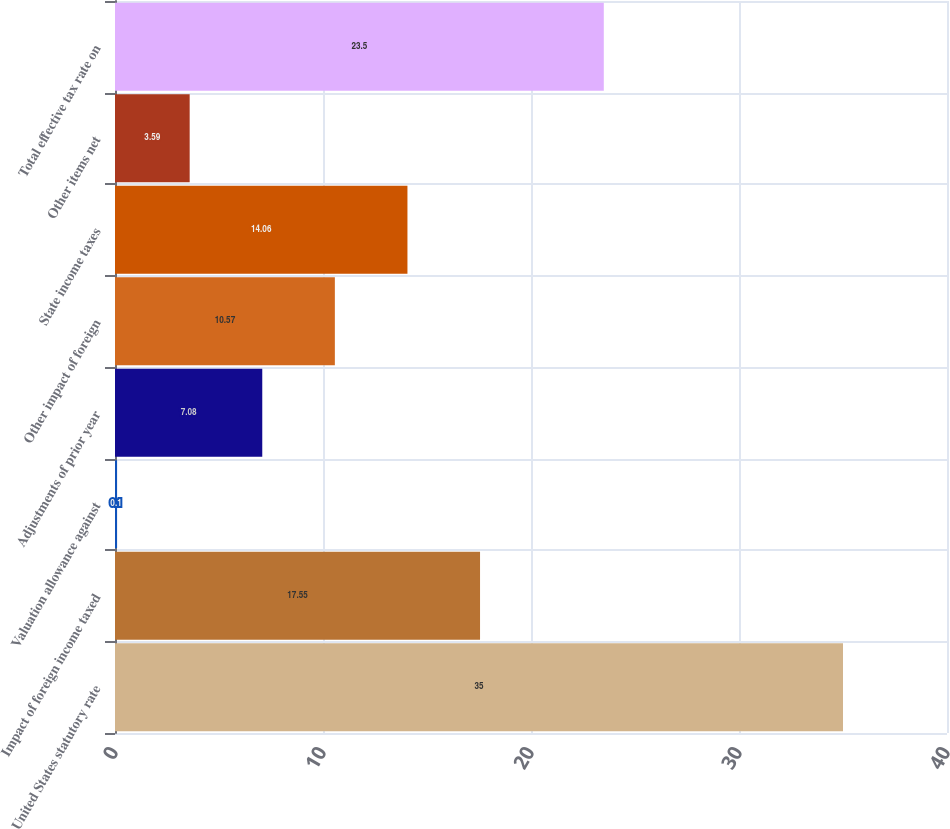Convert chart. <chart><loc_0><loc_0><loc_500><loc_500><bar_chart><fcel>United States statutory rate<fcel>Impact of foreign income taxed<fcel>Valuation allowance against<fcel>Adjustments of prior year<fcel>Other impact of foreign<fcel>State income taxes<fcel>Other items net<fcel>Total effective tax rate on<nl><fcel>35<fcel>17.55<fcel>0.1<fcel>7.08<fcel>10.57<fcel>14.06<fcel>3.59<fcel>23.5<nl></chart> 